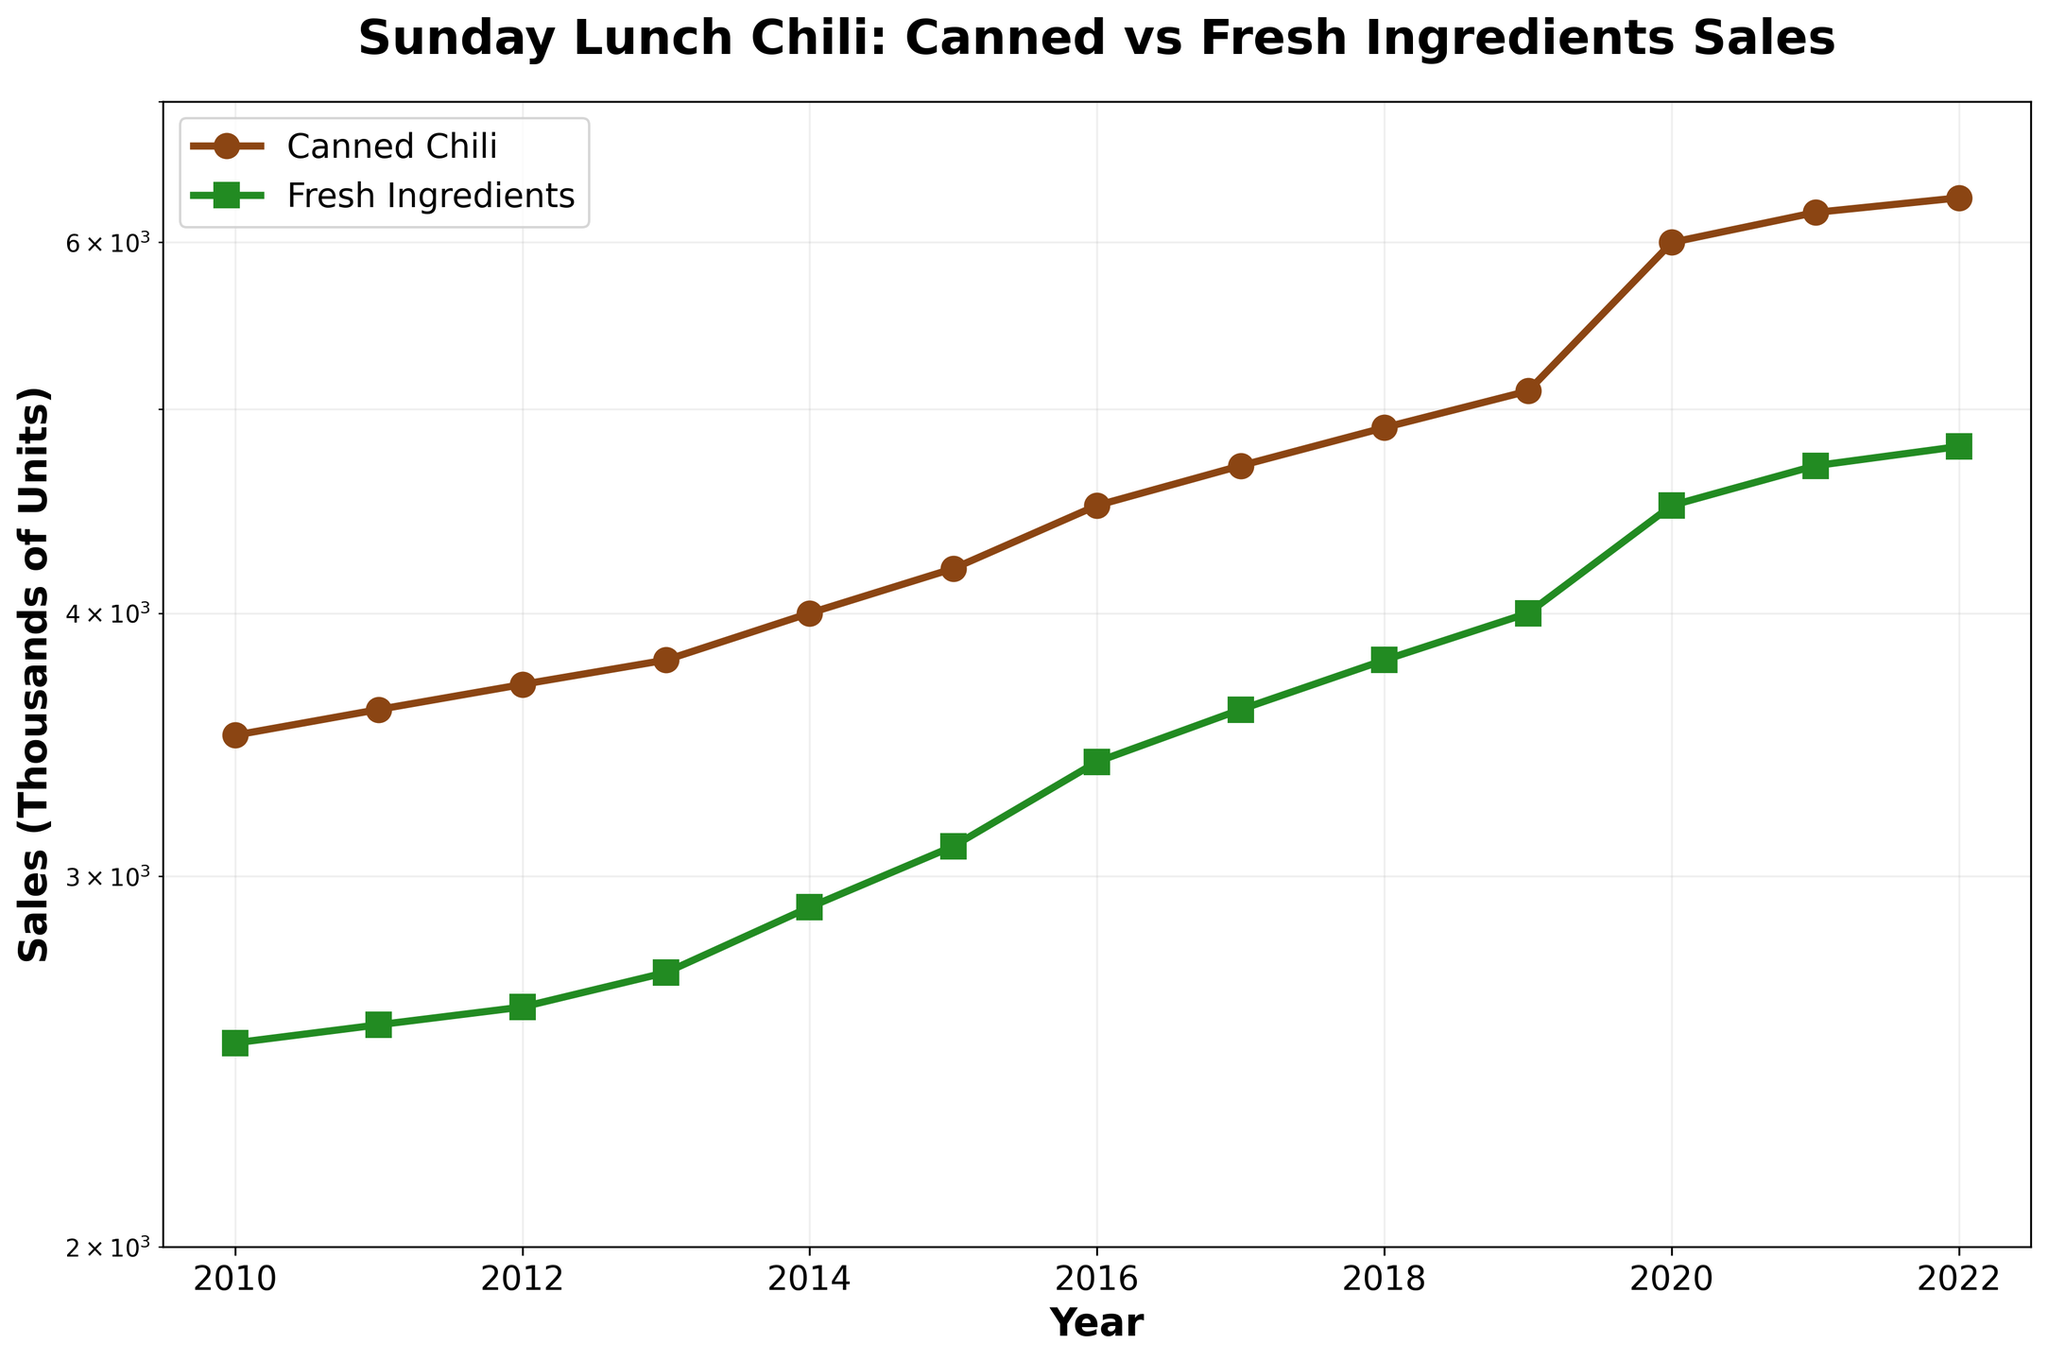What is the title of the graph? The title is displayed at the top of the graph in large bold text.
Answer: "Sunday Lunch Chili: Canned vs Fresh Ingredients Sales" What does the x-axis represent? The x-axis is labeled with "Year" and shows the range from 2010 to 2022.
Answer: Year What does the y-axis represent and what is its scale? The y-axis is labeled with "Sales (Thousands of Units)" and is on a logarithmic scale, as indicated by the log scale axis.
Answer: Sales (Thousands of Units), Logarithmic Which type of ingredient saw a higher increase in sales from 2010 to 2022, canned chili or fresh ingredients? By observing the two lines, the canned chili line shows a steeper increase compared to the fresh ingredients line.
Answer: Canned chili What is the difference in sales between canned chili and fresh ingredients in 2020? In 2020, the sales of canned chili were 6000 thousand units, and fresh ingredients were 4500 thousand units. Subtracting these gives: 6000 - 4500 = 1500 thousand units.
Answer: 1500 thousand units Which year shows the biggest annual increase in sales for canned chili? The biggest jump in the line for canned chili occurs between 2019 and 2020, where sales increased from 5100 to 6000 thousand units.
Answer: Between 2019 and 2020 By how much did the sales of fresh ingredients increase from 2012 to 2022? In 2012, the sales of fresh ingredients were 2600 thousand units, and in 2022, it was 4800 thousand units. The increase is: 4800 - 2600 = 2200 thousand units.
Answer: 2200 thousand units Are the sales of fresh ingredients in 2015 higher or lower than the sales of canned chili in 2011? The sales of fresh ingredients in 2015 were 3100 thousand units, which is higher than the sales of canned chili in 2011 at 3600 thousand units.
Answer: Lower What is the sales trend for both canned chili and fresh ingredients between 2010 and 2022? Observing both lines, sales of both canned chili and fresh ingredients show a generally upward trend over the years.
Answer: Upward trend In which year did canned chili sales first surpass 5000 thousand units? The line for canned chili crosses the 5000 thousand units mark in the year 2019.
Answer: 2019 